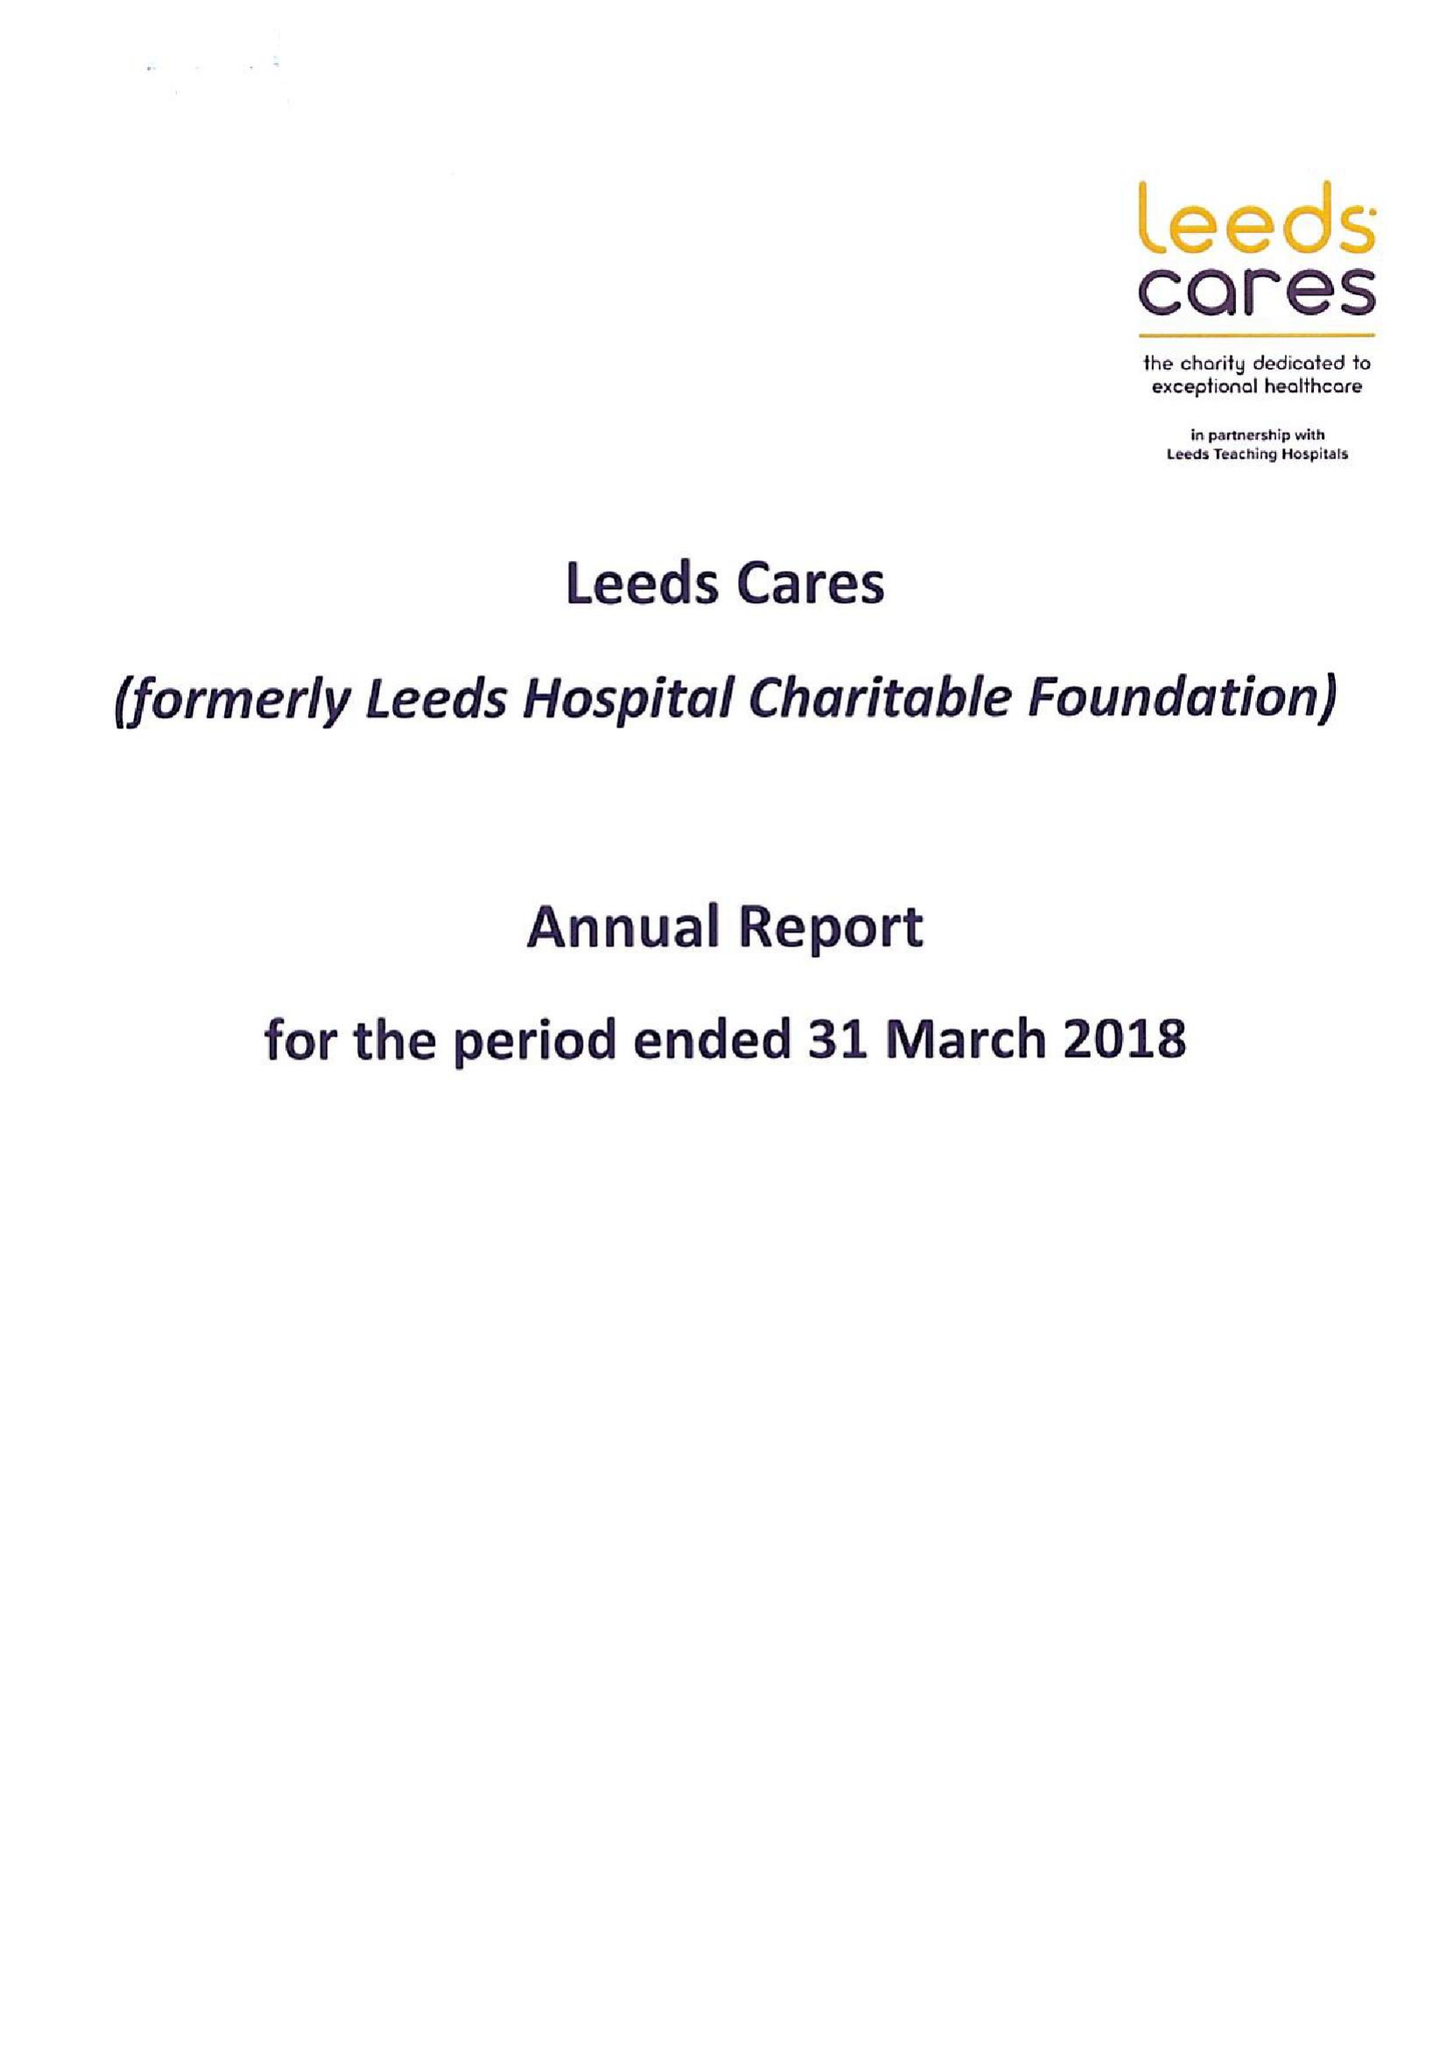What is the value for the charity_number?
Answer the question using a single word or phrase. 1170369 